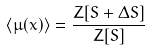Convert formula to latex. <formula><loc_0><loc_0><loc_500><loc_500>\langle \mu ( x ) \rangle = \frac { Z [ S + \Delta S ] } { Z [ S ] }</formula> 